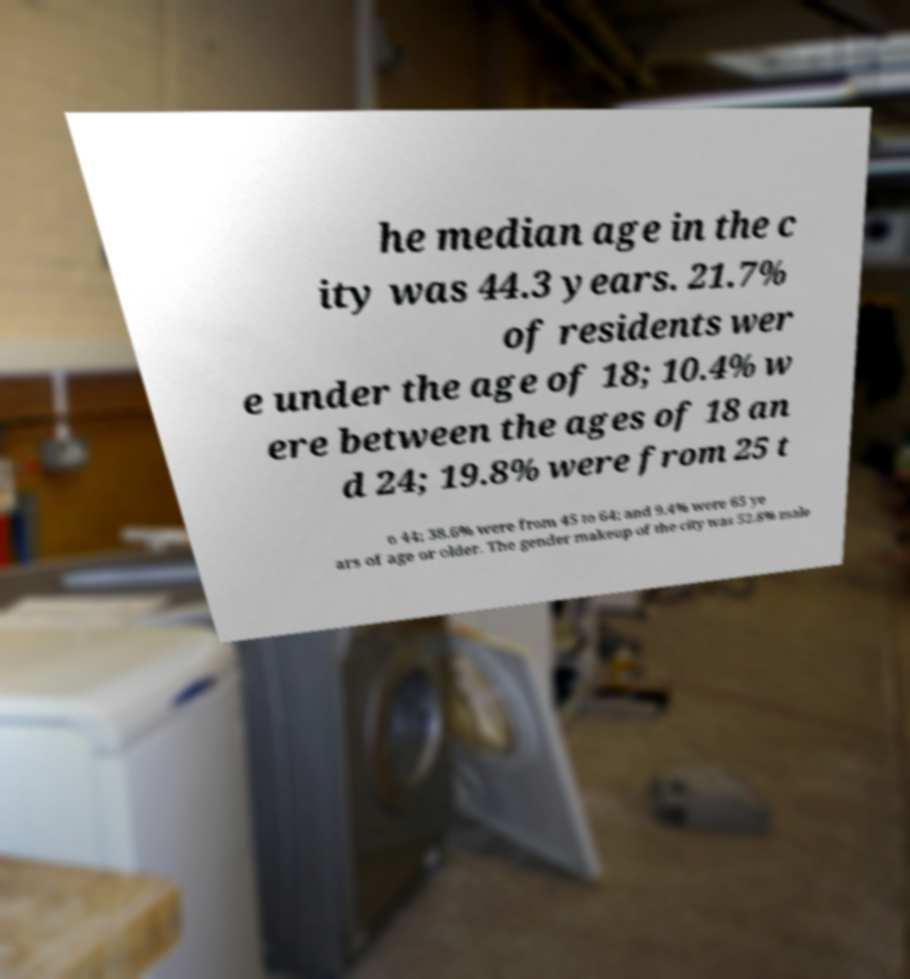There's text embedded in this image that I need extracted. Can you transcribe it verbatim? he median age in the c ity was 44.3 years. 21.7% of residents wer e under the age of 18; 10.4% w ere between the ages of 18 an d 24; 19.8% were from 25 t o 44; 38.6% were from 45 to 64; and 9.4% were 65 ye ars of age or older. The gender makeup of the city was 52.8% male 